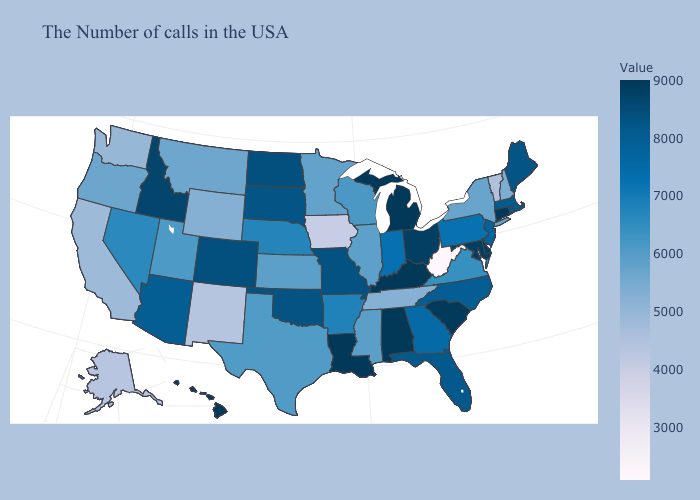Which states have the lowest value in the South?
Write a very short answer. West Virginia. Does Idaho have the lowest value in the USA?
Concise answer only. No. Does Hawaii have the highest value in the West?
Quick response, please. Yes. Which states have the lowest value in the Northeast?
Keep it brief. Vermont. Which states hav the highest value in the MidWest?
Concise answer only. Michigan. 